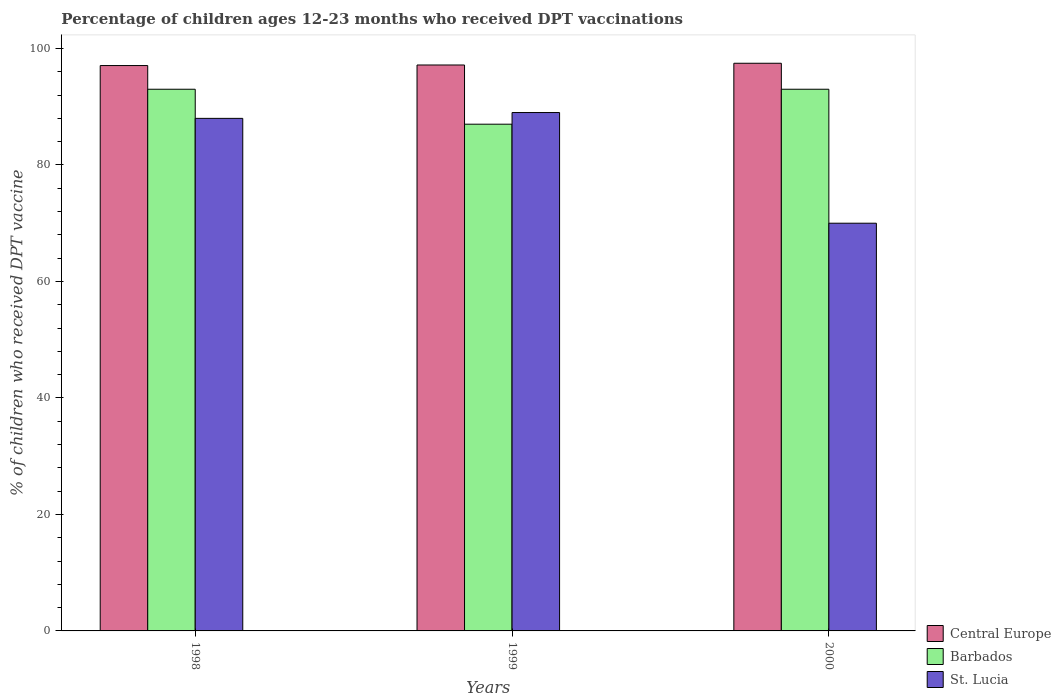Are the number of bars on each tick of the X-axis equal?
Your answer should be compact. Yes. In how many cases, is the number of bars for a given year not equal to the number of legend labels?
Offer a terse response. 0. What is the percentage of children who received DPT vaccination in St. Lucia in 1999?
Offer a terse response. 89. Across all years, what is the maximum percentage of children who received DPT vaccination in Central Europe?
Your answer should be compact. 97.46. Across all years, what is the minimum percentage of children who received DPT vaccination in Central Europe?
Your answer should be very brief. 97.07. What is the total percentage of children who received DPT vaccination in Barbados in the graph?
Your answer should be compact. 273. What is the difference between the percentage of children who received DPT vaccination in Central Europe in 1999 and that in 2000?
Make the answer very short. -0.3. What is the difference between the percentage of children who received DPT vaccination in Central Europe in 1998 and the percentage of children who received DPT vaccination in Barbados in 1999?
Make the answer very short. 10.07. What is the average percentage of children who received DPT vaccination in St. Lucia per year?
Make the answer very short. 82.33. In the year 1998, what is the difference between the percentage of children who received DPT vaccination in Central Europe and percentage of children who received DPT vaccination in Barbados?
Give a very brief answer. 4.07. In how many years, is the percentage of children who received DPT vaccination in Central Europe greater than 64 %?
Provide a short and direct response. 3. What is the ratio of the percentage of children who received DPT vaccination in Barbados in 1998 to that in 1999?
Your response must be concise. 1.07. Is the percentage of children who received DPT vaccination in St. Lucia in 1999 less than that in 2000?
Offer a terse response. No. Is the difference between the percentage of children who received DPT vaccination in Central Europe in 1998 and 2000 greater than the difference between the percentage of children who received DPT vaccination in Barbados in 1998 and 2000?
Give a very brief answer. No. What is the difference between the highest and the second highest percentage of children who received DPT vaccination in Central Europe?
Make the answer very short. 0.3. What is the difference between the highest and the lowest percentage of children who received DPT vaccination in Central Europe?
Make the answer very short. 0.39. What does the 1st bar from the left in 1998 represents?
Your response must be concise. Central Europe. What does the 1st bar from the right in 2000 represents?
Give a very brief answer. St. Lucia. Does the graph contain grids?
Your answer should be compact. No. Where does the legend appear in the graph?
Your answer should be compact. Bottom right. How many legend labels are there?
Your response must be concise. 3. How are the legend labels stacked?
Offer a terse response. Vertical. What is the title of the graph?
Keep it short and to the point. Percentage of children ages 12-23 months who received DPT vaccinations. What is the label or title of the Y-axis?
Make the answer very short. % of children who received DPT vaccine. What is the % of children who received DPT vaccine of Central Europe in 1998?
Ensure brevity in your answer.  97.07. What is the % of children who received DPT vaccine in Barbados in 1998?
Offer a terse response. 93. What is the % of children who received DPT vaccine in St. Lucia in 1998?
Offer a very short reply. 88. What is the % of children who received DPT vaccine of Central Europe in 1999?
Your answer should be compact. 97.16. What is the % of children who received DPT vaccine of Barbados in 1999?
Give a very brief answer. 87. What is the % of children who received DPT vaccine of St. Lucia in 1999?
Provide a short and direct response. 89. What is the % of children who received DPT vaccine in Central Europe in 2000?
Give a very brief answer. 97.46. What is the % of children who received DPT vaccine in Barbados in 2000?
Keep it short and to the point. 93. Across all years, what is the maximum % of children who received DPT vaccine in Central Europe?
Offer a very short reply. 97.46. Across all years, what is the maximum % of children who received DPT vaccine in Barbados?
Provide a succinct answer. 93. Across all years, what is the maximum % of children who received DPT vaccine in St. Lucia?
Provide a succinct answer. 89. Across all years, what is the minimum % of children who received DPT vaccine of Central Europe?
Provide a short and direct response. 97.07. Across all years, what is the minimum % of children who received DPT vaccine of St. Lucia?
Ensure brevity in your answer.  70. What is the total % of children who received DPT vaccine in Central Europe in the graph?
Keep it short and to the point. 291.69. What is the total % of children who received DPT vaccine of Barbados in the graph?
Make the answer very short. 273. What is the total % of children who received DPT vaccine of St. Lucia in the graph?
Your response must be concise. 247. What is the difference between the % of children who received DPT vaccine of Central Europe in 1998 and that in 1999?
Your response must be concise. -0.1. What is the difference between the % of children who received DPT vaccine of St. Lucia in 1998 and that in 1999?
Provide a succinct answer. -1. What is the difference between the % of children who received DPT vaccine of Central Europe in 1998 and that in 2000?
Keep it short and to the point. -0.39. What is the difference between the % of children who received DPT vaccine in Central Europe in 1999 and that in 2000?
Give a very brief answer. -0.3. What is the difference between the % of children who received DPT vaccine in St. Lucia in 1999 and that in 2000?
Give a very brief answer. 19. What is the difference between the % of children who received DPT vaccine of Central Europe in 1998 and the % of children who received DPT vaccine of Barbados in 1999?
Your response must be concise. 10.07. What is the difference between the % of children who received DPT vaccine in Central Europe in 1998 and the % of children who received DPT vaccine in St. Lucia in 1999?
Your response must be concise. 8.07. What is the difference between the % of children who received DPT vaccine of Barbados in 1998 and the % of children who received DPT vaccine of St. Lucia in 1999?
Your answer should be very brief. 4. What is the difference between the % of children who received DPT vaccine of Central Europe in 1998 and the % of children who received DPT vaccine of Barbados in 2000?
Your response must be concise. 4.07. What is the difference between the % of children who received DPT vaccine of Central Europe in 1998 and the % of children who received DPT vaccine of St. Lucia in 2000?
Offer a terse response. 27.07. What is the difference between the % of children who received DPT vaccine of Barbados in 1998 and the % of children who received DPT vaccine of St. Lucia in 2000?
Provide a short and direct response. 23. What is the difference between the % of children who received DPT vaccine of Central Europe in 1999 and the % of children who received DPT vaccine of Barbados in 2000?
Offer a terse response. 4.16. What is the difference between the % of children who received DPT vaccine in Central Europe in 1999 and the % of children who received DPT vaccine in St. Lucia in 2000?
Your answer should be compact. 27.16. What is the difference between the % of children who received DPT vaccine in Barbados in 1999 and the % of children who received DPT vaccine in St. Lucia in 2000?
Provide a succinct answer. 17. What is the average % of children who received DPT vaccine of Central Europe per year?
Your answer should be compact. 97.23. What is the average % of children who received DPT vaccine of Barbados per year?
Offer a terse response. 91. What is the average % of children who received DPT vaccine in St. Lucia per year?
Give a very brief answer. 82.33. In the year 1998, what is the difference between the % of children who received DPT vaccine in Central Europe and % of children who received DPT vaccine in Barbados?
Your answer should be very brief. 4.07. In the year 1998, what is the difference between the % of children who received DPT vaccine of Central Europe and % of children who received DPT vaccine of St. Lucia?
Give a very brief answer. 9.07. In the year 1998, what is the difference between the % of children who received DPT vaccine of Barbados and % of children who received DPT vaccine of St. Lucia?
Your answer should be very brief. 5. In the year 1999, what is the difference between the % of children who received DPT vaccine of Central Europe and % of children who received DPT vaccine of Barbados?
Make the answer very short. 10.16. In the year 1999, what is the difference between the % of children who received DPT vaccine in Central Europe and % of children who received DPT vaccine in St. Lucia?
Make the answer very short. 8.16. In the year 2000, what is the difference between the % of children who received DPT vaccine of Central Europe and % of children who received DPT vaccine of Barbados?
Your response must be concise. 4.46. In the year 2000, what is the difference between the % of children who received DPT vaccine in Central Europe and % of children who received DPT vaccine in St. Lucia?
Give a very brief answer. 27.46. In the year 2000, what is the difference between the % of children who received DPT vaccine in Barbados and % of children who received DPT vaccine in St. Lucia?
Give a very brief answer. 23. What is the ratio of the % of children who received DPT vaccine in Central Europe in 1998 to that in 1999?
Your response must be concise. 1. What is the ratio of the % of children who received DPT vaccine of Barbados in 1998 to that in 1999?
Make the answer very short. 1.07. What is the ratio of the % of children who received DPT vaccine of St. Lucia in 1998 to that in 1999?
Offer a very short reply. 0.99. What is the ratio of the % of children who received DPT vaccine of St. Lucia in 1998 to that in 2000?
Keep it short and to the point. 1.26. What is the ratio of the % of children who received DPT vaccine in Central Europe in 1999 to that in 2000?
Offer a very short reply. 1. What is the ratio of the % of children who received DPT vaccine of Barbados in 1999 to that in 2000?
Give a very brief answer. 0.94. What is the ratio of the % of children who received DPT vaccine of St. Lucia in 1999 to that in 2000?
Provide a succinct answer. 1.27. What is the difference between the highest and the second highest % of children who received DPT vaccine of Central Europe?
Keep it short and to the point. 0.3. What is the difference between the highest and the second highest % of children who received DPT vaccine in St. Lucia?
Offer a terse response. 1. What is the difference between the highest and the lowest % of children who received DPT vaccine in Central Europe?
Your answer should be very brief. 0.39. What is the difference between the highest and the lowest % of children who received DPT vaccine of Barbados?
Your answer should be very brief. 6. What is the difference between the highest and the lowest % of children who received DPT vaccine of St. Lucia?
Make the answer very short. 19. 